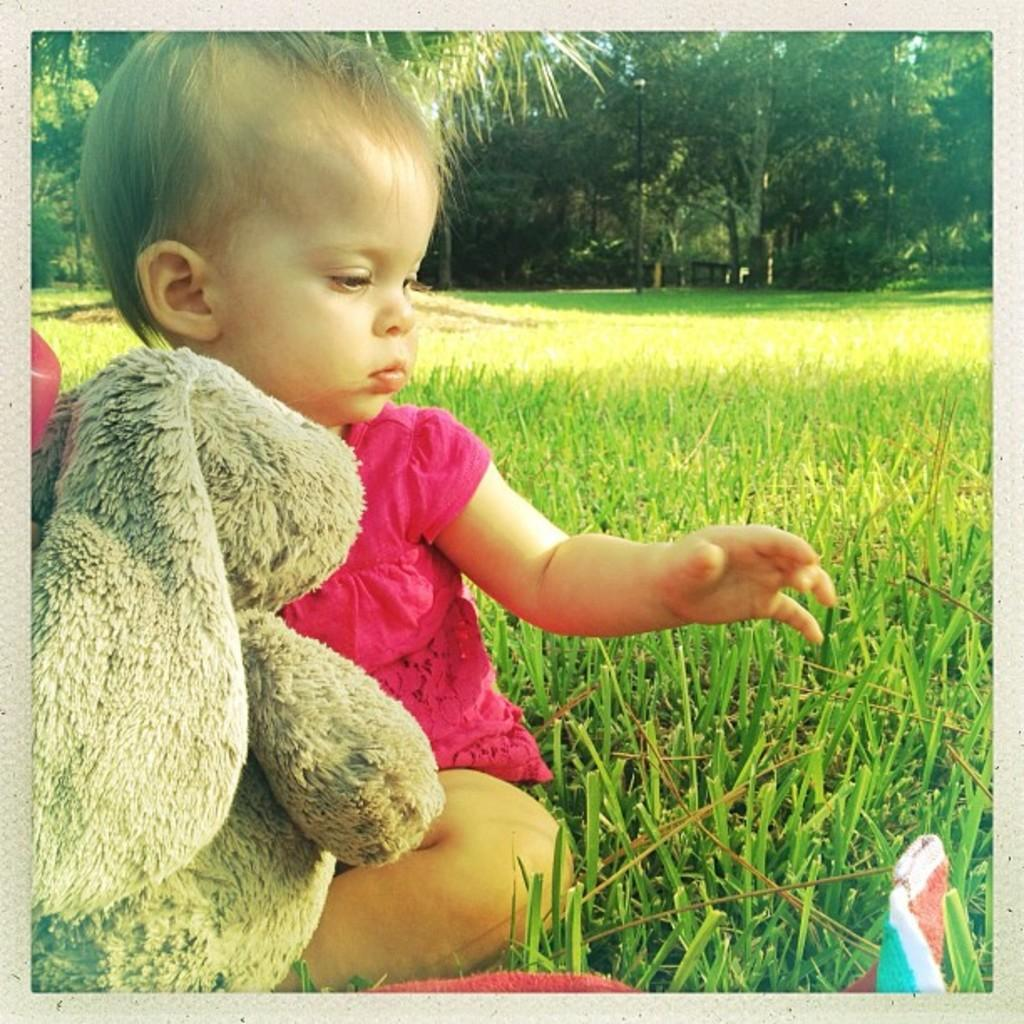What is the main subject of the image? The main subject of the image is a kid. Where is the kid located in the image? The kid is sitting on the grass in the image. What is the primary element in the center of the image? The grass is in the center of the image. What can be seen in the background of the image? There are trees in the background of the image. What type of hat is the queen wearing in the image? There is no queen or hat present in the image; it features a kid sitting on the grass. 